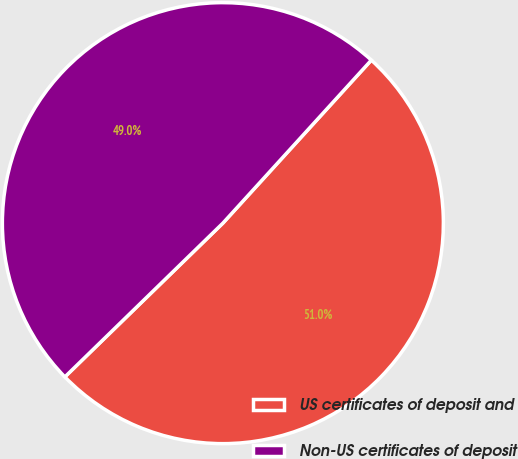Convert chart to OTSL. <chart><loc_0><loc_0><loc_500><loc_500><pie_chart><fcel>US certificates of deposit and<fcel>Non-US certificates of deposit<nl><fcel>50.96%<fcel>49.04%<nl></chart> 